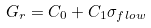<formula> <loc_0><loc_0><loc_500><loc_500>G _ { r } = C _ { 0 } + C _ { 1 } \sigma _ { f l o w }</formula> 